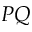Convert formula to latex. <formula><loc_0><loc_0><loc_500><loc_500>P Q</formula> 